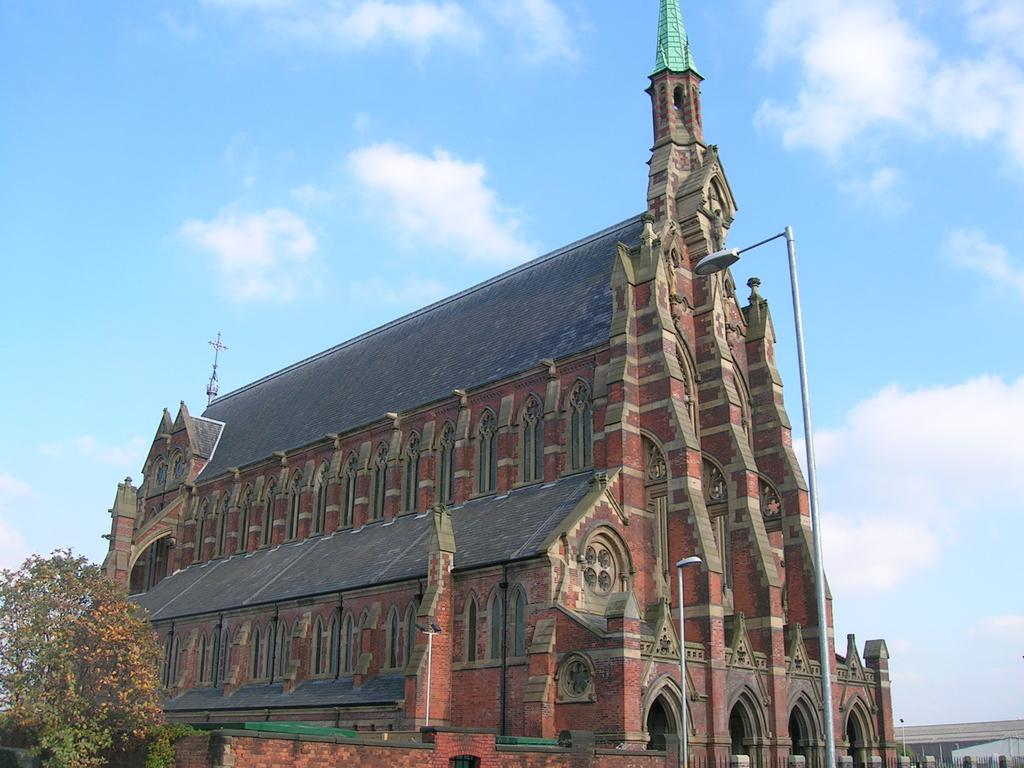What objects are in the foreground of the image? There are two poles in the foreground of the image. What can be seen on the left side of the image? There is a tree on the left side of the image. What type of structure is present in the image? There is a building in the image. What is visible at the top of the image? The sky is visible at the top of the image. What is the amount of wax used to create the scent in the image? There is no mention of wax or scent in the image; it features two poles, a tree, a building, and the sky. 